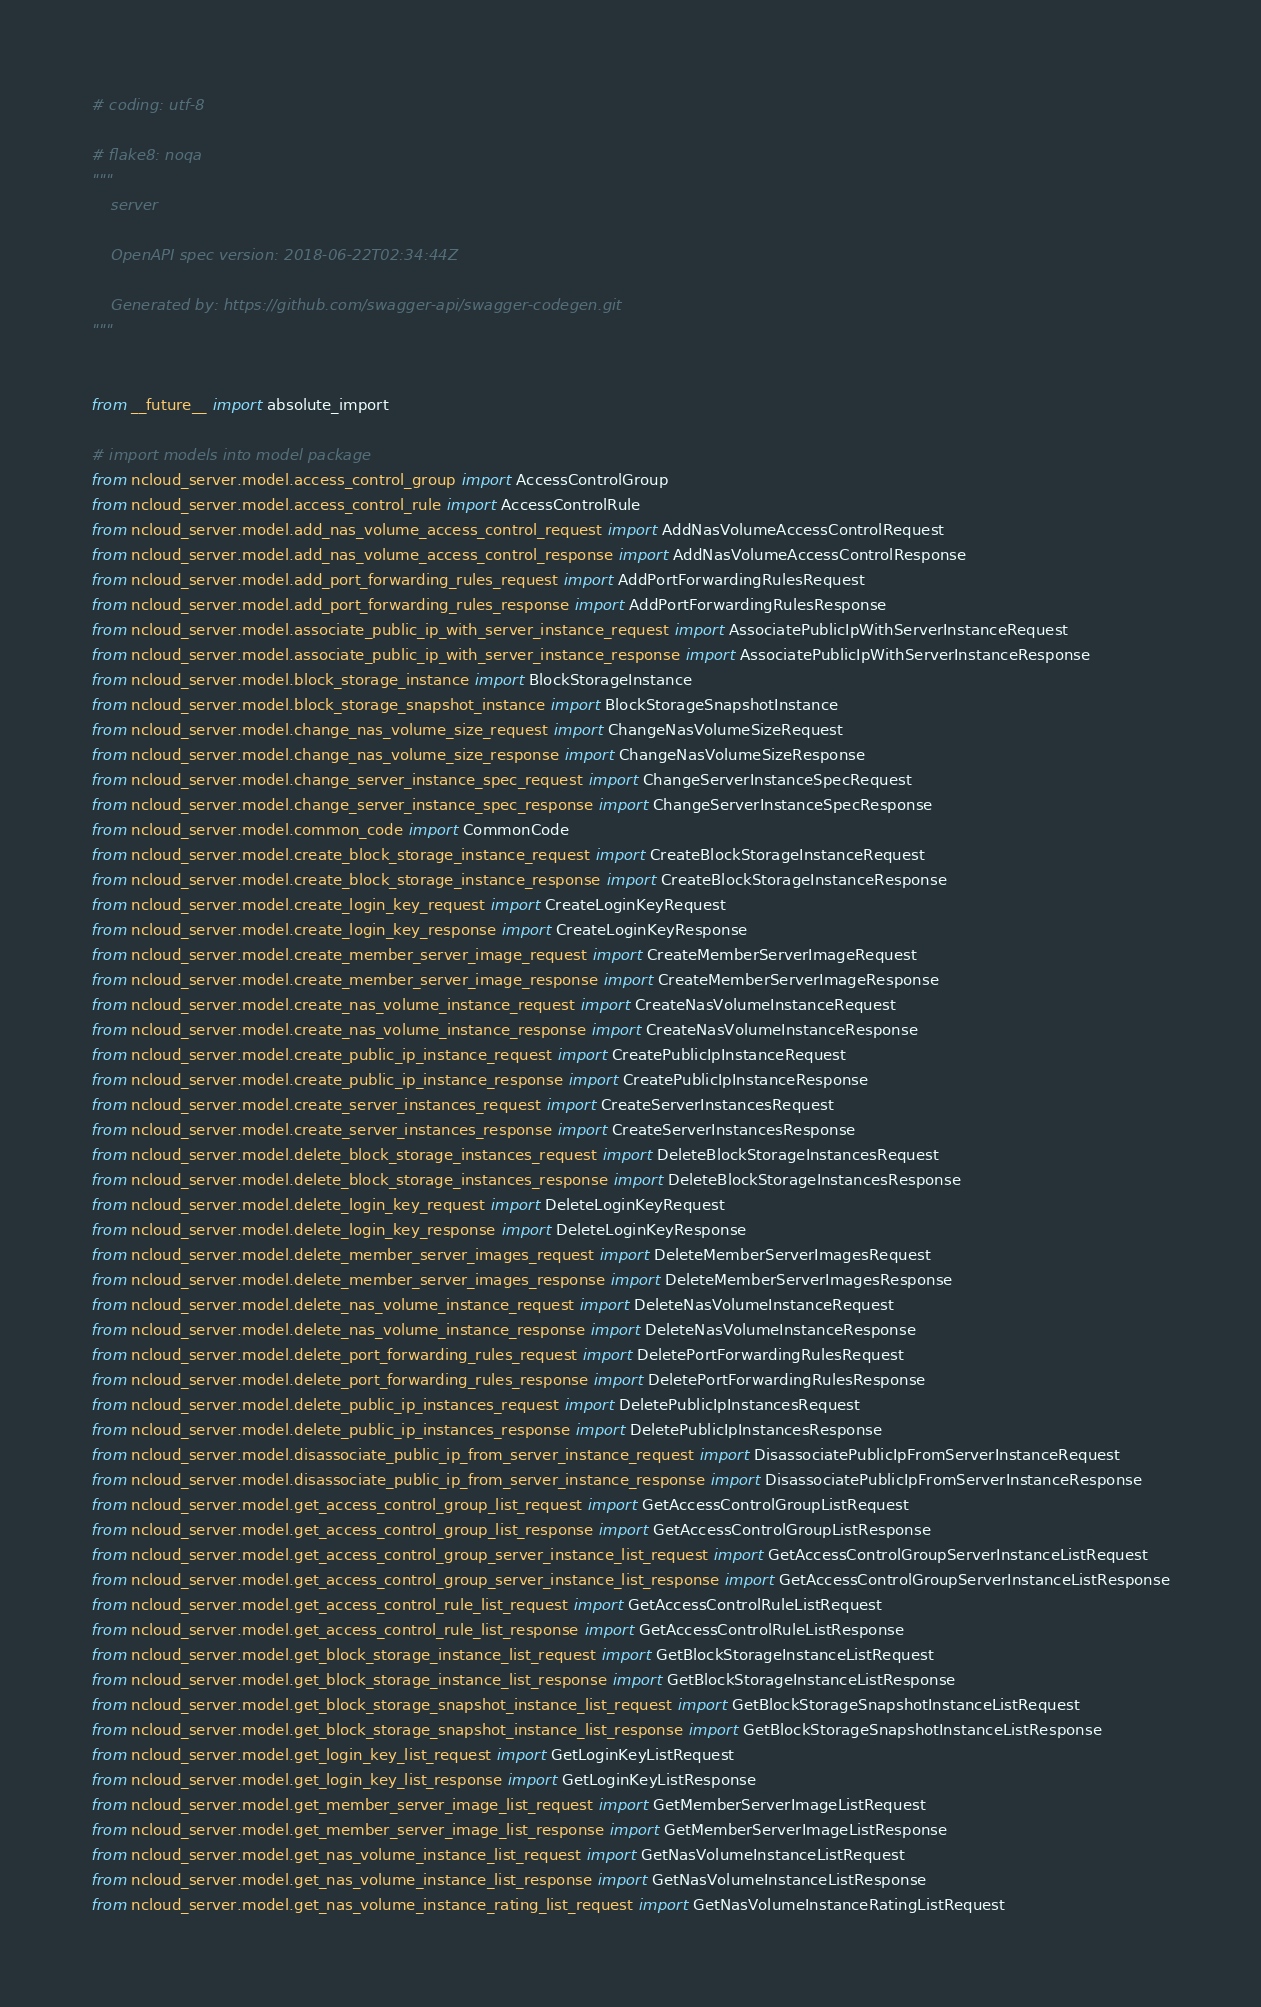<code> <loc_0><loc_0><loc_500><loc_500><_Python_># coding: utf-8

# flake8: noqa
"""
    server

    OpenAPI spec version: 2018-06-22T02:34:44Z
    
    Generated by: https://github.com/swagger-api/swagger-codegen.git
"""


from __future__ import absolute_import

# import models into model package
from ncloud_server.model.access_control_group import AccessControlGroup
from ncloud_server.model.access_control_rule import AccessControlRule
from ncloud_server.model.add_nas_volume_access_control_request import AddNasVolumeAccessControlRequest
from ncloud_server.model.add_nas_volume_access_control_response import AddNasVolumeAccessControlResponse
from ncloud_server.model.add_port_forwarding_rules_request import AddPortForwardingRulesRequest
from ncloud_server.model.add_port_forwarding_rules_response import AddPortForwardingRulesResponse
from ncloud_server.model.associate_public_ip_with_server_instance_request import AssociatePublicIpWithServerInstanceRequest
from ncloud_server.model.associate_public_ip_with_server_instance_response import AssociatePublicIpWithServerInstanceResponse
from ncloud_server.model.block_storage_instance import BlockStorageInstance
from ncloud_server.model.block_storage_snapshot_instance import BlockStorageSnapshotInstance
from ncloud_server.model.change_nas_volume_size_request import ChangeNasVolumeSizeRequest
from ncloud_server.model.change_nas_volume_size_response import ChangeNasVolumeSizeResponse
from ncloud_server.model.change_server_instance_spec_request import ChangeServerInstanceSpecRequest
from ncloud_server.model.change_server_instance_spec_response import ChangeServerInstanceSpecResponse
from ncloud_server.model.common_code import CommonCode
from ncloud_server.model.create_block_storage_instance_request import CreateBlockStorageInstanceRequest
from ncloud_server.model.create_block_storage_instance_response import CreateBlockStorageInstanceResponse
from ncloud_server.model.create_login_key_request import CreateLoginKeyRequest
from ncloud_server.model.create_login_key_response import CreateLoginKeyResponse
from ncloud_server.model.create_member_server_image_request import CreateMemberServerImageRequest
from ncloud_server.model.create_member_server_image_response import CreateMemberServerImageResponse
from ncloud_server.model.create_nas_volume_instance_request import CreateNasVolumeInstanceRequest
from ncloud_server.model.create_nas_volume_instance_response import CreateNasVolumeInstanceResponse
from ncloud_server.model.create_public_ip_instance_request import CreatePublicIpInstanceRequest
from ncloud_server.model.create_public_ip_instance_response import CreatePublicIpInstanceResponse
from ncloud_server.model.create_server_instances_request import CreateServerInstancesRequest
from ncloud_server.model.create_server_instances_response import CreateServerInstancesResponse
from ncloud_server.model.delete_block_storage_instances_request import DeleteBlockStorageInstancesRequest
from ncloud_server.model.delete_block_storage_instances_response import DeleteBlockStorageInstancesResponse
from ncloud_server.model.delete_login_key_request import DeleteLoginKeyRequest
from ncloud_server.model.delete_login_key_response import DeleteLoginKeyResponse
from ncloud_server.model.delete_member_server_images_request import DeleteMemberServerImagesRequest
from ncloud_server.model.delete_member_server_images_response import DeleteMemberServerImagesResponse
from ncloud_server.model.delete_nas_volume_instance_request import DeleteNasVolumeInstanceRequest
from ncloud_server.model.delete_nas_volume_instance_response import DeleteNasVolumeInstanceResponse
from ncloud_server.model.delete_port_forwarding_rules_request import DeletePortForwardingRulesRequest
from ncloud_server.model.delete_port_forwarding_rules_response import DeletePortForwardingRulesResponse
from ncloud_server.model.delete_public_ip_instances_request import DeletePublicIpInstancesRequest
from ncloud_server.model.delete_public_ip_instances_response import DeletePublicIpInstancesResponse
from ncloud_server.model.disassociate_public_ip_from_server_instance_request import DisassociatePublicIpFromServerInstanceRequest
from ncloud_server.model.disassociate_public_ip_from_server_instance_response import DisassociatePublicIpFromServerInstanceResponse
from ncloud_server.model.get_access_control_group_list_request import GetAccessControlGroupListRequest
from ncloud_server.model.get_access_control_group_list_response import GetAccessControlGroupListResponse
from ncloud_server.model.get_access_control_group_server_instance_list_request import GetAccessControlGroupServerInstanceListRequest
from ncloud_server.model.get_access_control_group_server_instance_list_response import GetAccessControlGroupServerInstanceListResponse
from ncloud_server.model.get_access_control_rule_list_request import GetAccessControlRuleListRequest
from ncloud_server.model.get_access_control_rule_list_response import GetAccessControlRuleListResponse
from ncloud_server.model.get_block_storage_instance_list_request import GetBlockStorageInstanceListRequest
from ncloud_server.model.get_block_storage_instance_list_response import GetBlockStorageInstanceListResponse
from ncloud_server.model.get_block_storage_snapshot_instance_list_request import GetBlockStorageSnapshotInstanceListRequest
from ncloud_server.model.get_block_storage_snapshot_instance_list_response import GetBlockStorageSnapshotInstanceListResponse
from ncloud_server.model.get_login_key_list_request import GetLoginKeyListRequest
from ncloud_server.model.get_login_key_list_response import GetLoginKeyListResponse
from ncloud_server.model.get_member_server_image_list_request import GetMemberServerImageListRequest
from ncloud_server.model.get_member_server_image_list_response import GetMemberServerImageListResponse
from ncloud_server.model.get_nas_volume_instance_list_request import GetNasVolumeInstanceListRequest
from ncloud_server.model.get_nas_volume_instance_list_response import GetNasVolumeInstanceListResponse
from ncloud_server.model.get_nas_volume_instance_rating_list_request import GetNasVolumeInstanceRatingListRequest</code> 